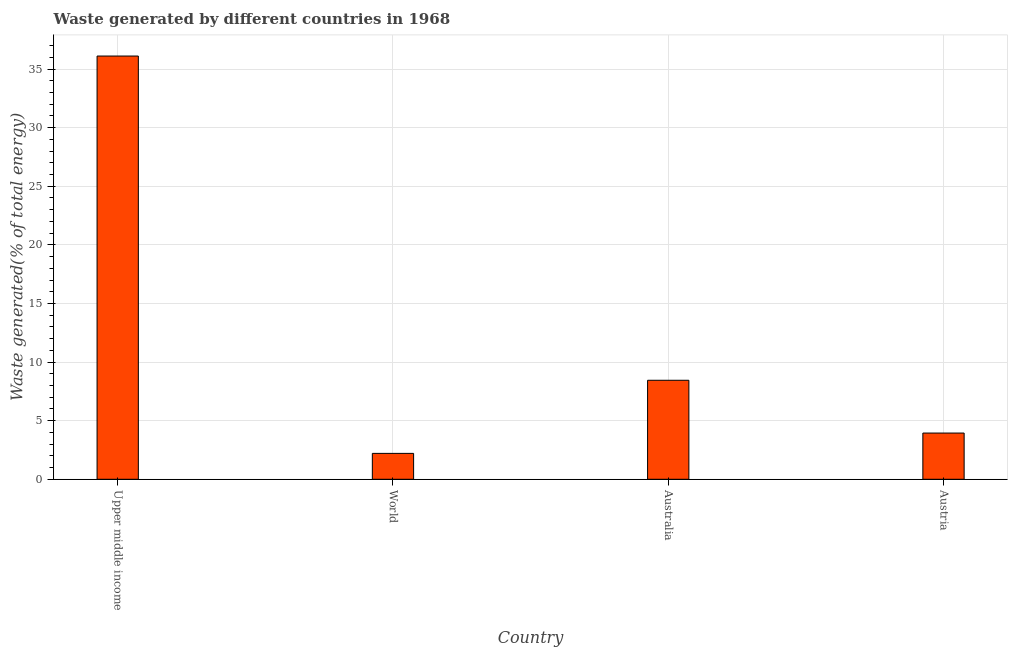Does the graph contain any zero values?
Your answer should be compact. No. Does the graph contain grids?
Your response must be concise. Yes. What is the title of the graph?
Offer a terse response. Waste generated by different countries in 1968. What is the label or title of the Y-axis?
Make the answer very short. Waste generated(% of total energy). What is the amount of waste generated in Australia?
Your response must be concise. 8.45. Across all countries, what is the maximum amount of waste generated?
Your response must be concise. 36.11. Across all countries, what is the minimum amount of waste generated?
Your answer should be very brief. 2.21. In which country was the amount of waste generated maximum?
Make the answer very short. Upper middle income. What is the sum of the amount of waste generated?
Ensure brevity in your answer.  50.71. What is the difference between the amount of waste generated in Austria and Upper middle income?
Make the answer very short. -32.17. What is the average amount of waste generated per country?
Offer a terse response. 12.68. What is the median amount of waste generated?
Provide a short and direct response. 6.2. In how many countries, is the amount of waste generated greater than 22 %?
Your answer should be compact. 1. What is the ratio of the amount of waste generated in Austria to that in Upper middle income?
Keep it short and to the point. 0.11. Is the amount of waste generated in Australia less than that in World?
Provide a short and direct response. No. What is the difference between the highest and the second highest amount of waste generated?
Offer a terse response. 27.66. Is the sum of the amount of waste generated in Australia and World greater than the maximum amount of waste generated across all countries?
Make the answer very short. No. What is the difference between the highest and the lowest amount of waste generated?
Provide a succinct answer. 33.9. In how many countries, is the amount of waste generated greater than the average amount of waste generated taken over all countries?
Ensure brevity in your answer.  1. How many countries are there in the graph?
Give a very brief answer. 4. What is the difference between two consecutive major ticks on the Y-axis?
Provide a short and direct response. 5. Are the values on the major ticks of Y-axis written in scientific E-notation?
Make the answer very short. No. What is the Waste generated(% of total energy) of Upper middle income?
Your answer should be compact. 36.11. What is the Waste generated(% of total energy) of World?
Keep it short and to the point. 2.21. What is the Waste generated(% of total energy) of Australia?
Your answer should be very brief. 8.45. What is the Waste generated(% of total energy) of Austria?
Make the answer very short. 3.94. What is the difference between the Waste generated(% of total energy) in Upper middle income and World?
Offer a very short reply. 33.9. What is the difference between the Waste generated(% of total energy) in Upper middle income and Australia?
Your answer should be compact. 27.66. What is the difference between the Waste generated(% of total energy) in Upper middle income and Austria?
Your answer should be very brief. 32.17. What is the difference between the Waste generated(% of total energy) in World and Australia?
Offer a terse response. -6.24. What is the difference between the Waste generated(% of total energy) in World and Austria?
Your answer should be compact. -1.73. What is the difference between the Waste generated(% of total energy) in Australia and Austria?
Offer a very short reply. 4.5. What is the ratio of the Waste generated(% of total energy) in Upper middle income to that in World?
Offer a terse response. 16.34. What is the ratio of the Waste generated(% of total energy) in Upper middle income to that in Australia?
Provide a short and direct response. 4.28. What is the ratio of the Waste generated(% of total energy) in Upper middle income to that in Austria?
Provide a succinct answer. 9.16. What is the ratio of the Waste generated(% of total energy) in World to that in Australia?
Keep it short and to the point. 0.26. What is the ratio of the Waste generated(% of total energy) in World to that in Austria?
Offer a very short reply. 0.56. What is the ratio of the Waste generated(% of total energy) in Australia to that in Austria?
Make the answer very short. 2.14. 